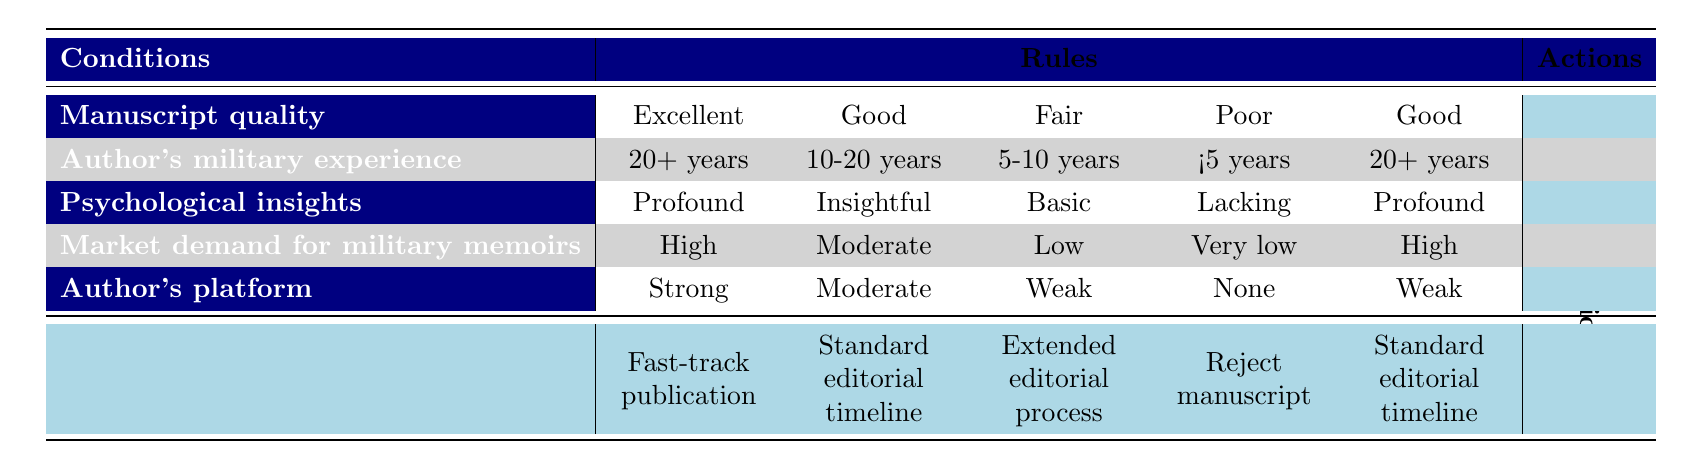What decision is made for a manuscript with excellent quality and over 20 years of military experience? The table indicates that for a manuscript that is rated as "Excellent" and has an author's military experience of "20+ years," the decision is to "Fast-track publication."
Answer: Fast-track publication What is the action taken for a manuscript with fair quality and a weak author platform? According to the table, a manuscript with "Fair" quality and a "Weak" author platform, along with other conditions of low market demand and basic psychological insights, results in an "Extended editorial process."
Answer: Extended editorial process Is there a situation where a manuscript with good quality and low market demand will lead to a rejection? The table does not show any scenario where a manuscript categorized as "Good" quality leads to a "Reject manuscript" action, so the answer is no.
Answer: No How many conditions are applicable for a "Standard editorial timeline" decision? The table reveals that there are three instances where the decision is "Standard editorial timeline," with varying conditions for manuscript quality and author experience. So, there are multiple paths to reach this decision.
Answer: Three What is the decision for a fair quality manuscript with profound psychological insights and 20+ years of military experience? For a manuscript described as "Fair" quality, with "Profound" psychological insights and "20+ years" of military experience, the table indicates the decision is "Extended editorial process."
Answer: Extended editorial process If an author has profound psychological insights but their manuscript quality is poor, what is the action taken? Based on the table, regardless of having "Profound" psychological insights, a "Poor" manuscript quality leads directly to a "Reject manuscript" decision, as seen in the relevant rule.
Answer: Reject manuscript What could lead to fast-tracking a memoir publication? To fast-track publication, the authors must have an "Excellent" quality manuscript, "20+ years" of military experience, "Profound" psychological insights, "High" market demand, and a "Strong" author platform; this combination is the only rule leading to such a decision.
Answer: Excellent quality, 20+ years military experience, profound insights, high demand, strong platform In the scenario where the manuscript is categorized as "Good," what could change the action from "Standard editorial timeline" to "Extended editorial process"? If a manuscript rated as "Good" has a weak author platform or is accompanied by lower market demand along with fewer years of military experience or basic psychological insights, it could change the decision from "Standard editorial timeline" to "Extended editorial process."
Answer: Weak platform or lower demand 